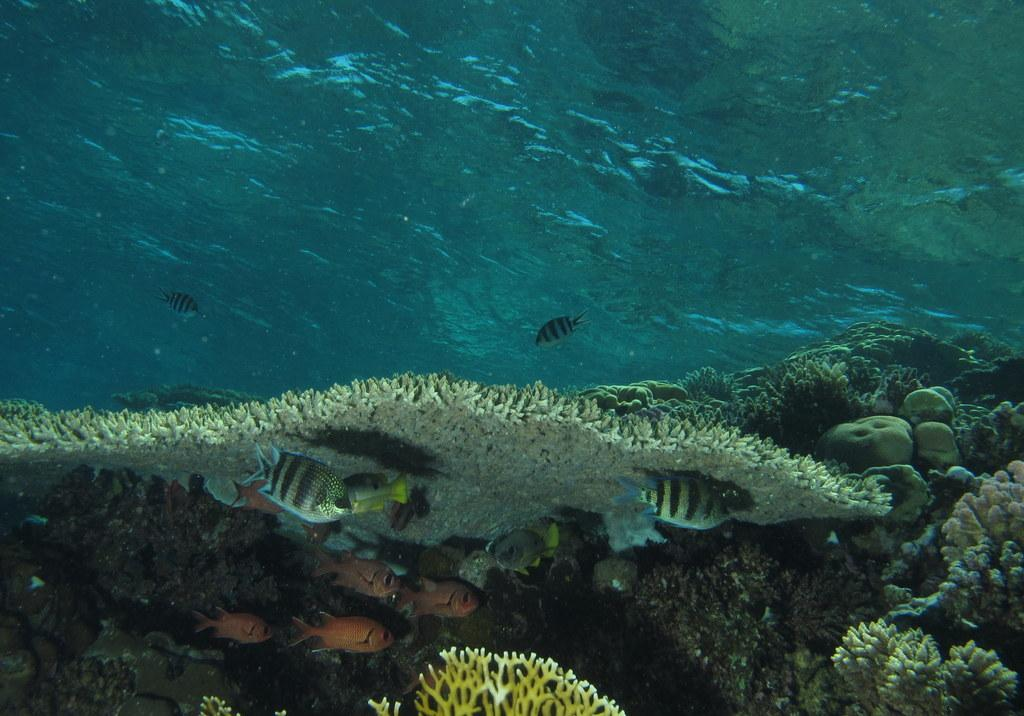What type of animals can be seen in the image? There are fish in the image. What other living organisms are present in the image? There are aquatic plants in the image. What is the primary element in which the fish and plants are situated? The water is visible in the image. What is the color of the water in the image? The water is blue in color. What type of letter is the doctor holding in the image? There is no doctor or letter present in the image; it features fish and aquatic plants in blue water. 